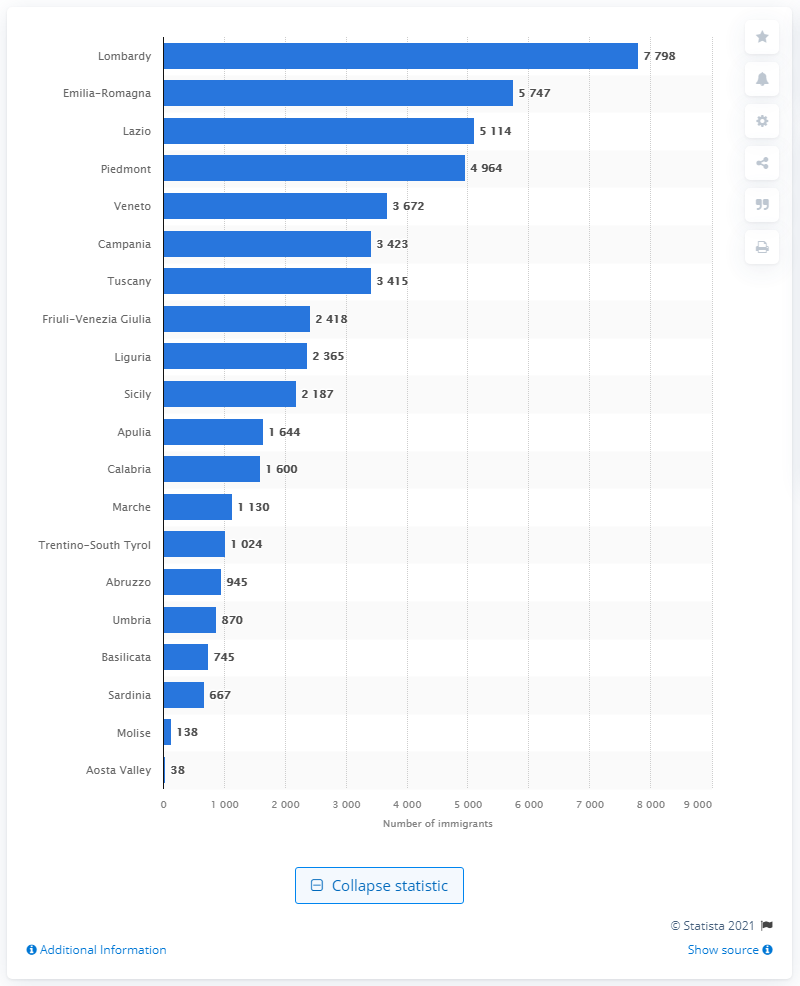List a handful of essential elements in this visual. According to data from April 2021, Lombardy, a region in North-Italy, hosted the highest number of immigrants in reception centers. 